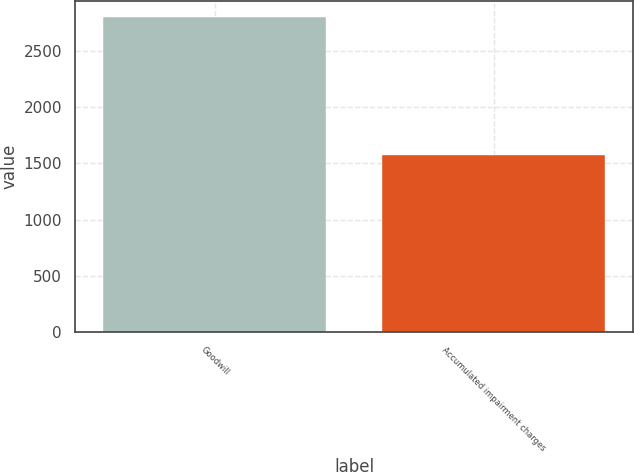Convert chart. <chart><loc_0><loc_0><loc_500><loc_500><bar_chart><fcel>Goodwill<fcel>Accumulated impairment charges<nl><fcel>2803.2<fcel>1571.4<nl></chart> 